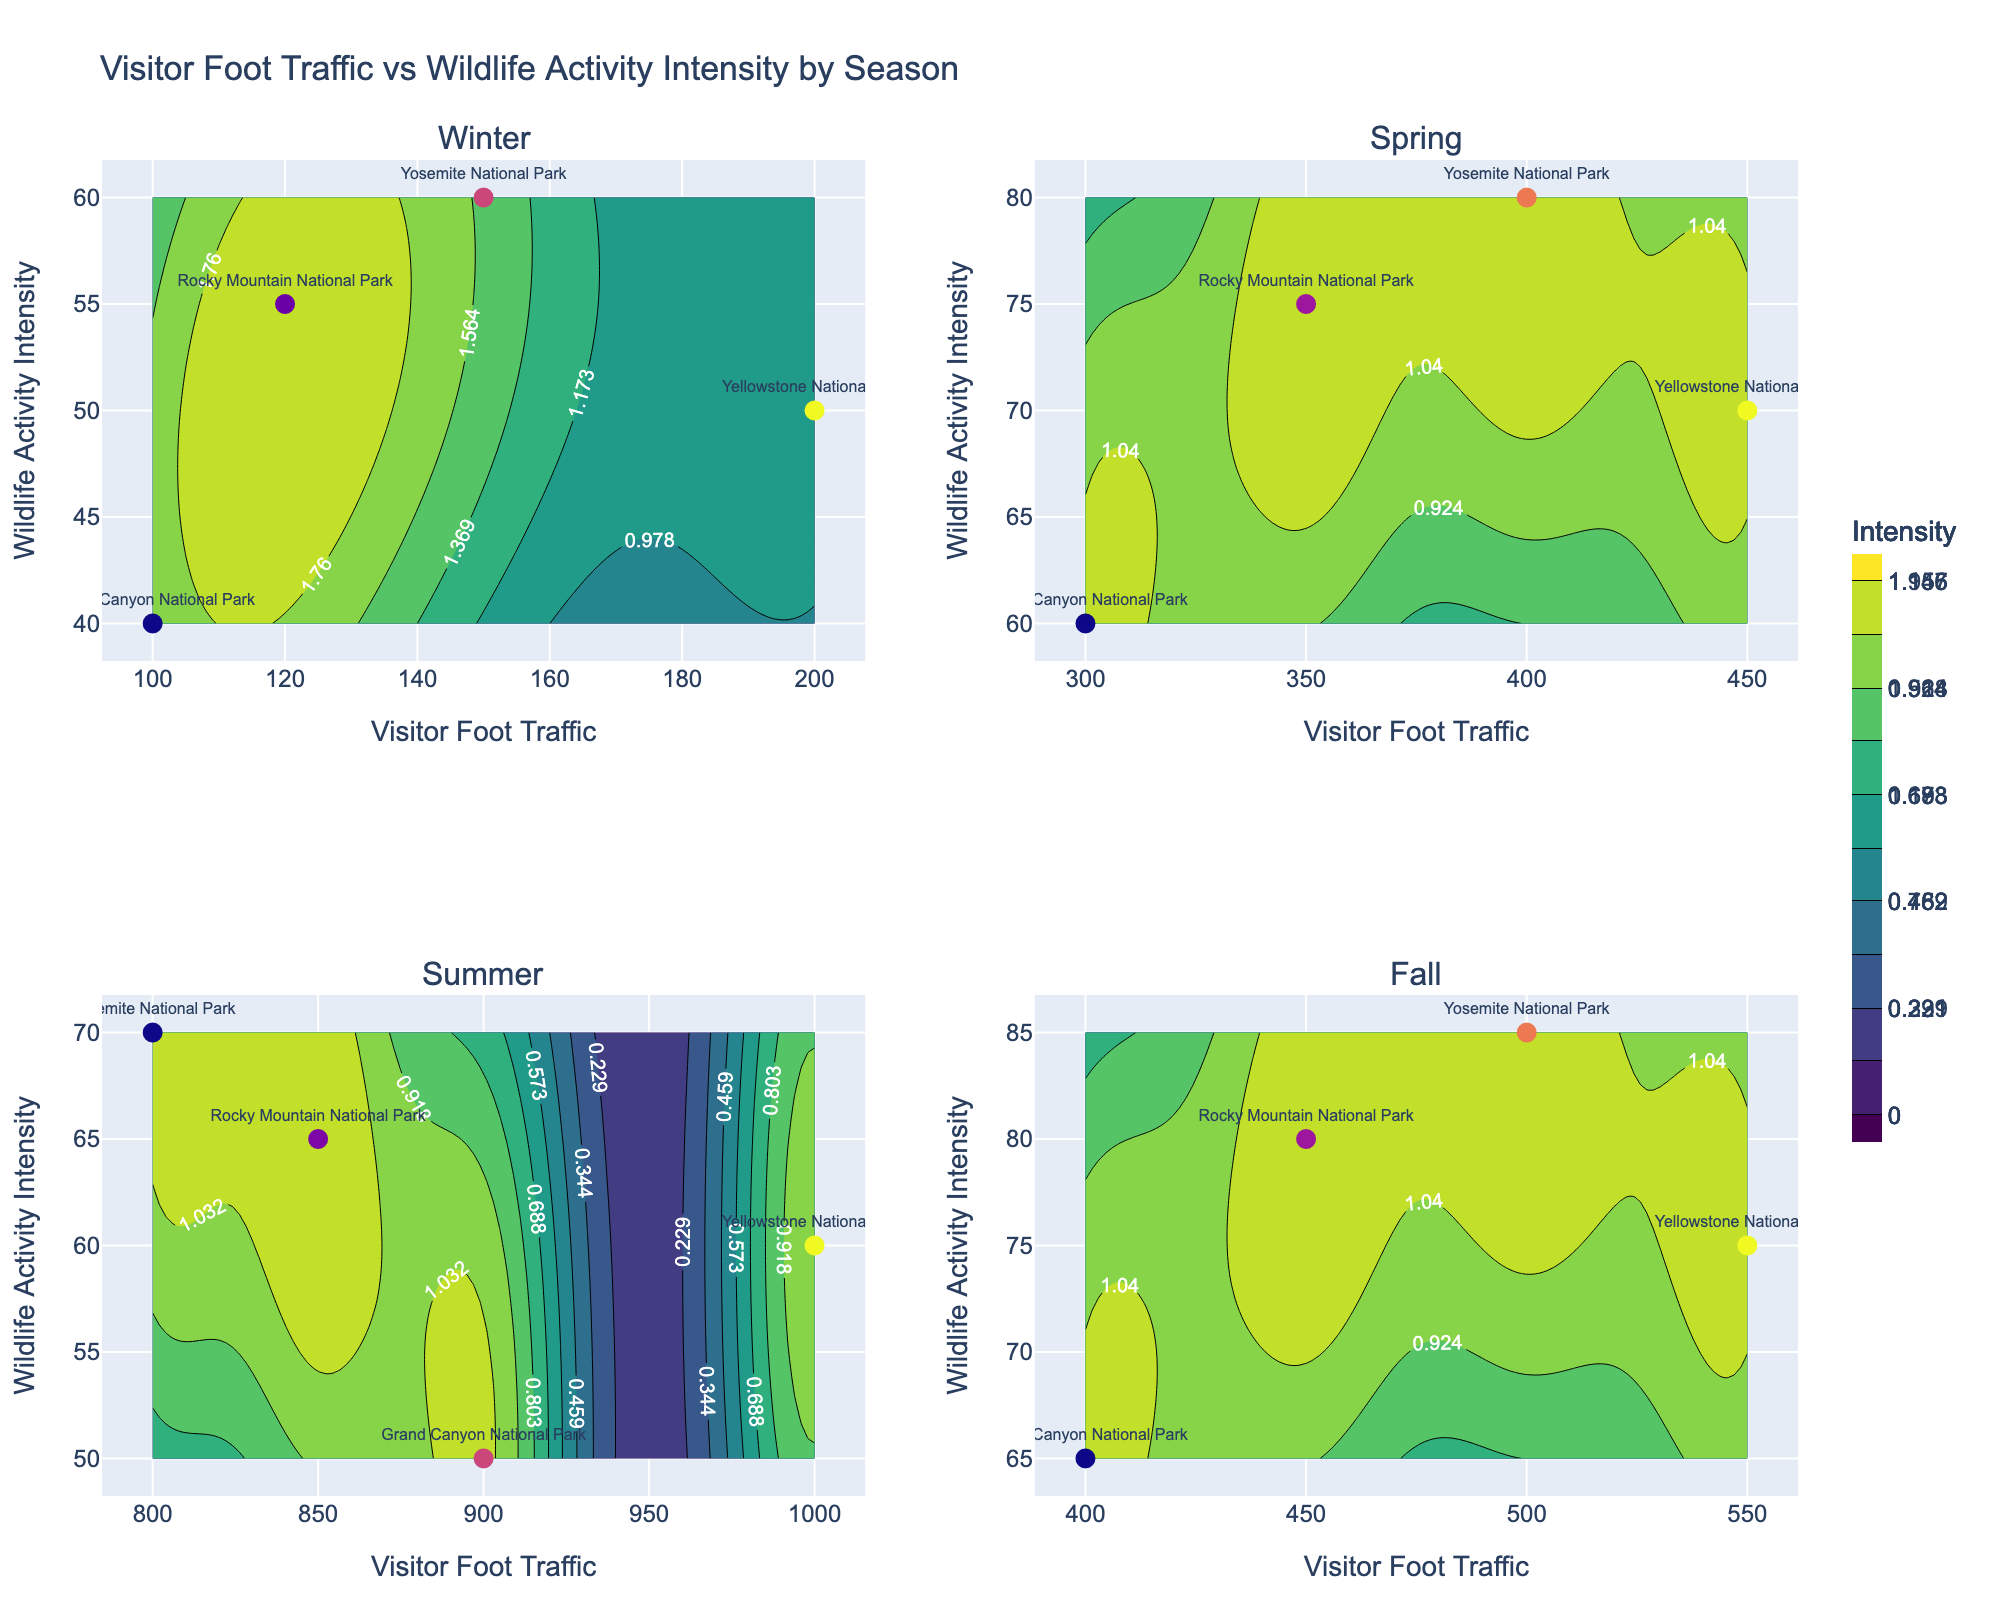what's the title of the figure? The title of the figure is usually located at the top of the plot. In this case, you would see "Visitor Foot Traffic vs Wildlife Activity Intensity by Season".
Answer: Visitor Foot Traffic vs Wildlife Activity Intensity by Season In which season does Yellowstone National Park have the highest visitor foot traffic? By examining the individual subplots, notice the markers in each season's subplot. In the summer subplot, Yellowstone National Park has the highest number at 1000.
Answer: Summer What is the relationship between visitor foot traffic and wildlife activity intensity in winter? Look at the contour lines and scatter points in the winter subplot. As the visitor foot traffic increases, wildlife activity intensity does not show significant increase; it stays largely around 50-60.
Answer: No strong positive correlation Which season shows the highest variation in wildlife activity intensity? Check the spread of the y-values (Wildlife Activity Intensity) in all subplots. Spring shows the widest range, from around 60 to 80.
Answer: Spring Is there any season where all parks have similar wildlife activity intensity? Compare the y-values in each subplot. In winter, all parks have wildlife activity intensities clustered around 40-60.
Answer: Winter Which park has the highest wildlife activity intensity overall and in which season? By comparing the highest points in each subplot, Yosemite in Fall reaches an intensity of 85.
Answer: Yosemite National Park in Fall How does visitor foot traffic in Spring compare to Winter for Grand Canyon National Park? Look at the respective subplots; Spring has 300 visitors, and Winter has 100. The difference is 200.
Answer: Spring has 200 more visitors than Winter Which season has the highest average visitor foot traffic across all parks? Calculate the average visitor foot traffic for each season. Summer: (800 + 1000 + 900 + 850)/4 = 887.5 Spring: (400 + 450 + 300 + 350)/4 = 375
Answer: Summer Are there any seasons where increased visitor foot traffic significantly correlates with decreased wildlife activity intensity? Examine the downward trends in the contour lines and scatter plots. In Summer, this trend is observed as traffic increases and intensity slightly decreases.
Answer: Summer How does the intensity distribution in Fall compare to Spring? Compare the shapes and ranges of the intensity values for both seasons. In Fall, the intensity values range around 65-85, whereas in Spring it ranges from 60-80.
Answer: Slightly higher and more varied in Fall 